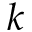Convert formula to latex. <formula><loc_0><loc_0><loc_500><loc_500>k</formula> 